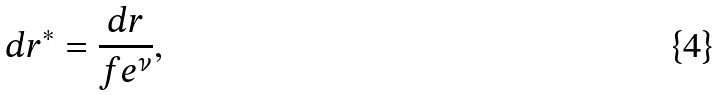Convert formula to latex. <formula><loc_0><loc_0><loc_500><loc_500>& d r ^ { * } = \frac { d r } { f e ^ { \nu } } ,</formula> 